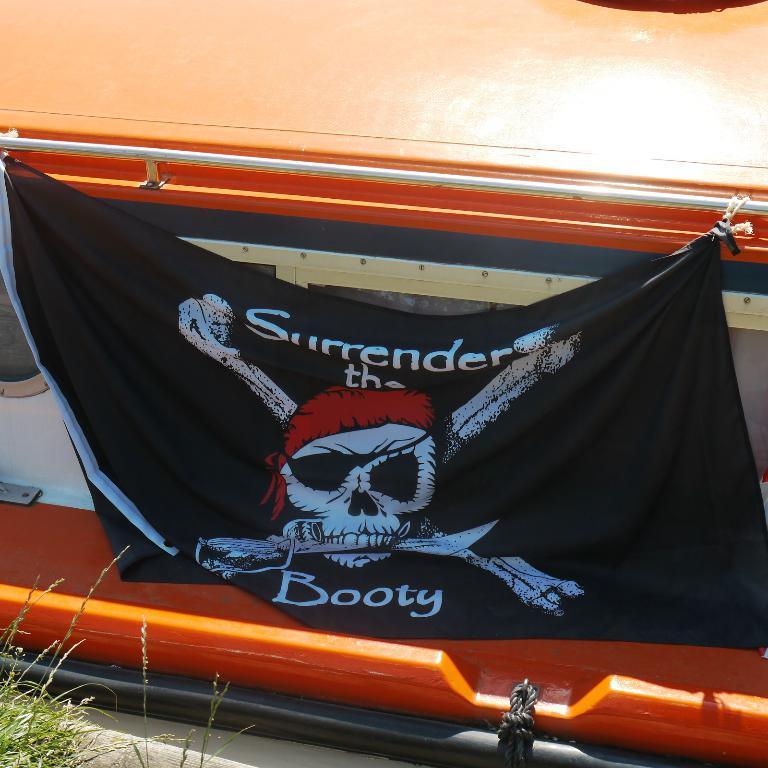Can you describe this image briefly? Black flag is tied to this boat. Here we can see rope and grass. On this black flag there is a skeleton. 